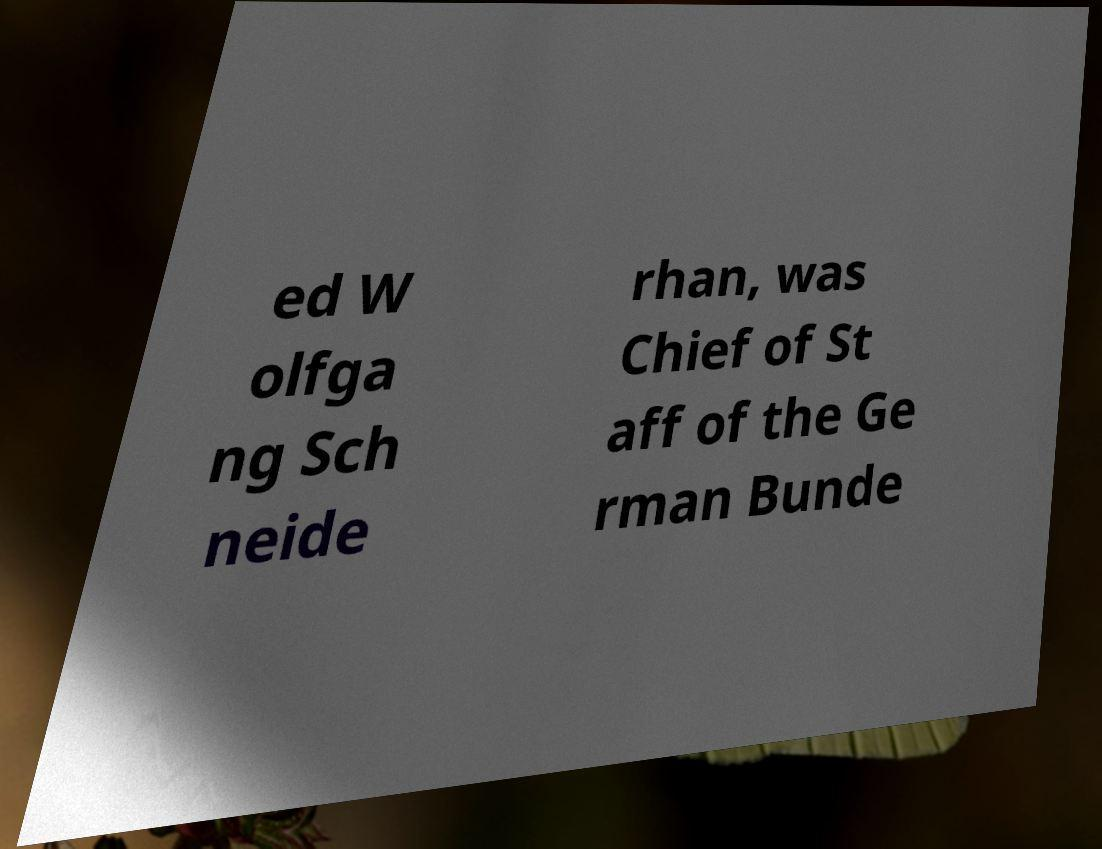Can you accurately transcribe the text from the provided image for me? ed W olfga ng Sch neide rhan, was Chief of St aff of the Ge rman Bunde 